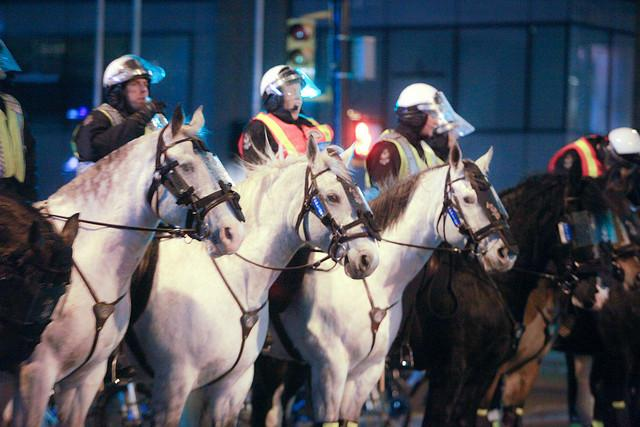What body part is protected by the attachment on the helmets they are wearing? head 